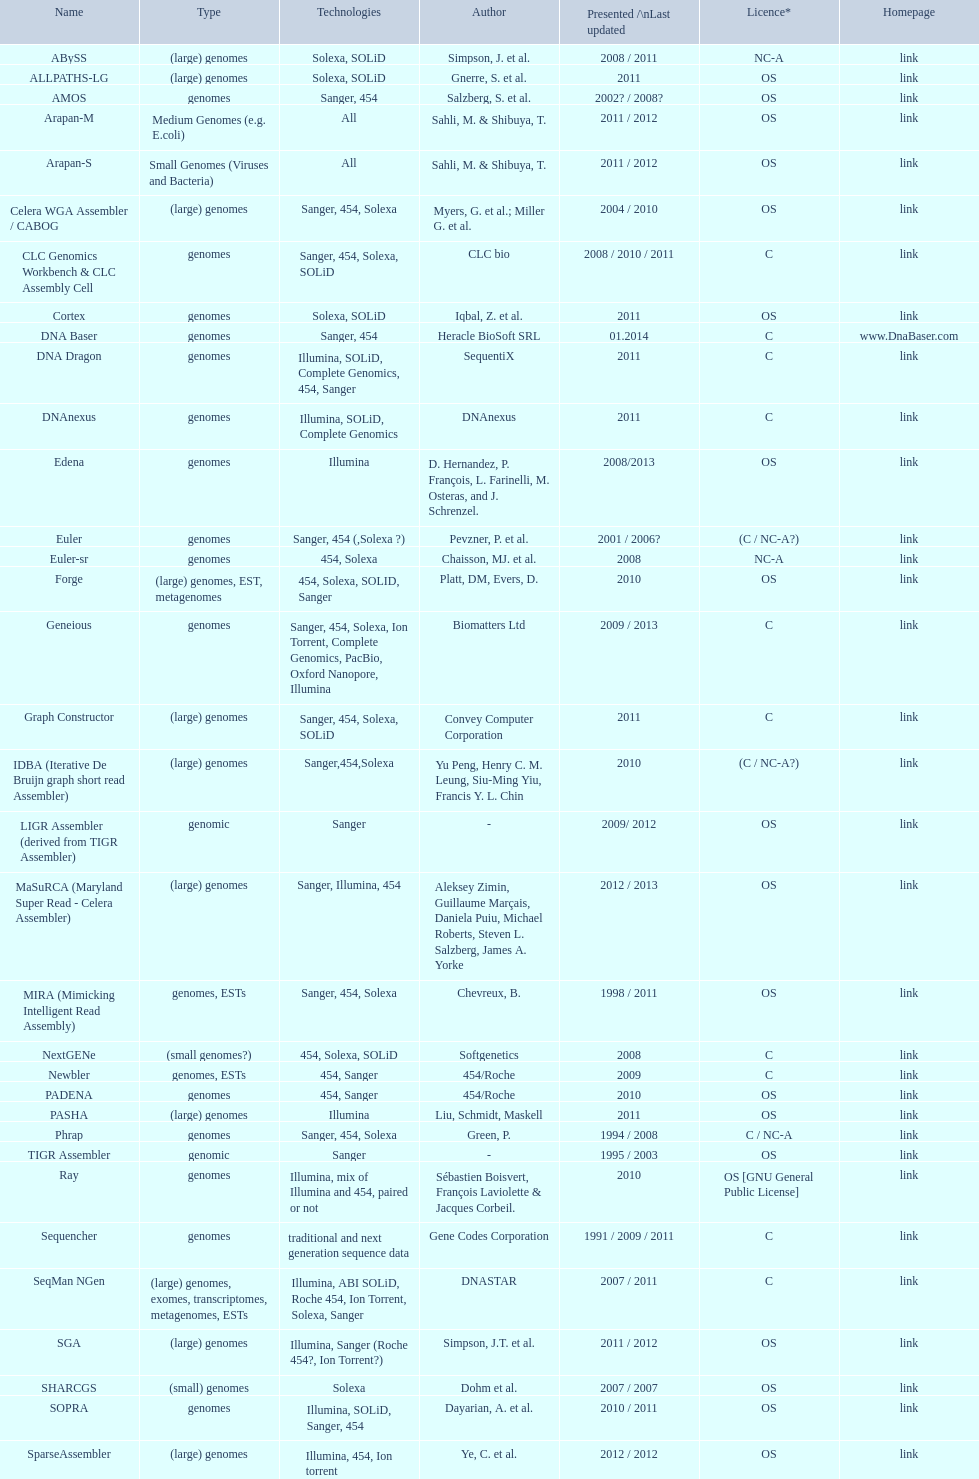How many are listed as "all" technologies? 2. 